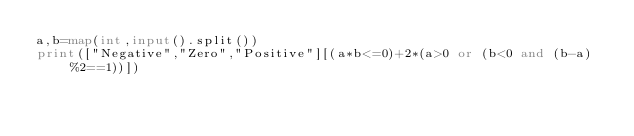<code> <loc_0><loc_0><loc_500><loc_500><_Python_>a,b=map(int,input().split())
print(["Negative","Zero","Positive"][(a*b<=0)+2*(a>0 or (b<0 and (b-a)%2==1))])</code> 